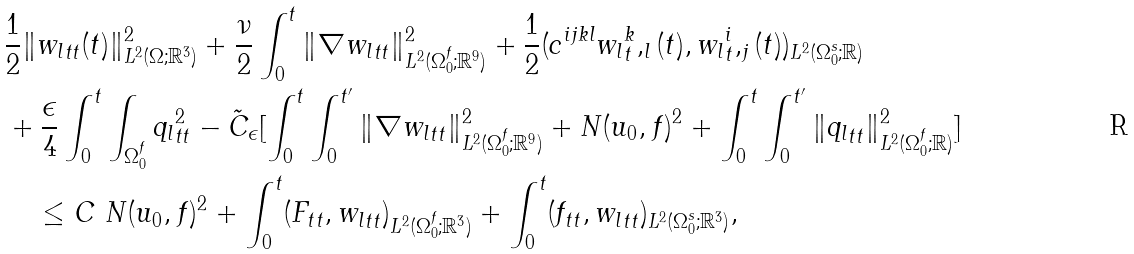<formula> <loc_0><loc_0><loc_500><loc_500>& { \frac { 1 } { 2 } } \| { w _ { l } } _ { t t } ( t ) \| ^ { 2 } _ { L ^ { 2 } ( \Omega ; { \mathbb { R } } ^ { 3 } ) } + \frac { \nu } { 2 } \int _ { 0 } ^ { t } \| \nabla { w _ { l } } _ { t t } \| ^ { 2 } _ { L ^ { 2 } ( \Omega _ { 0 } ^ { f } ; { \mathbb { R } } ^ { 9 } ) } + \frac { 1 } { 2 } ( c ^ { i j k l } { w _ { l } } _ { t } ^ { k } , _ { l } ( t ) , { w _ { l } } _ { t } ^ { i } , _ { j } ( t ) ) _ { L ^ { 2 } ( \Omega _ { 0 } ^ { s } ; { \mathbb { R } } ) } \\ & + \frac { \epsilon } { 4 } \int _ { 0 } ^ { t } \int _ { \Omega _ { 0 } ^ { f } } { q _ { l } } ^ { 2 } _ { t t } - \tilde { C } _ { \epsilon } [ \int _ { 0 } ^ { t } \int _ { 0 } ^ { t ^ { \prime } } \| \nabla { w _ { l } } _ { t t } \| ^ { 2 } _ { L ^ { 2 } ( \Omega _ { 0 } ^ { f } ; { \mathbb { R } } ^ { 9 } ) } + N ( u _ { 0 } , f ) ^ { 2 } + \int _ { 0 } ^ { t } \int _ { 0 } ^ { t ^ { \prime } } \| { q _ { l } } _ { t t } \| ^ { 2 } _ { L ^ { 2 } ( \Omega _ { 0 } ^ { f } ; { \mathbb { R } } ) } ] \\ & \quad \leq C \ N ( u _ { 0 } , f ) ^ { 2 } + \int _ { 0 } ^ { t } ( F _ { t t } , { w _ { l } } _ { t t } ) _ { L ^ { 2 } ( \Omega _ { 0 } ^ { f } ; { \mathbb { R } } ^ { 3 } ) } + \int _ { 0 } ^ { t } ( f _ { t t } , { w _ { l } } _ { t t } ) _ { L ^ { 2 } ( \Omega _ { 0 } ^ { s } ; { \mathbb { R } } ^ { 3 } ) } ,</formula> 